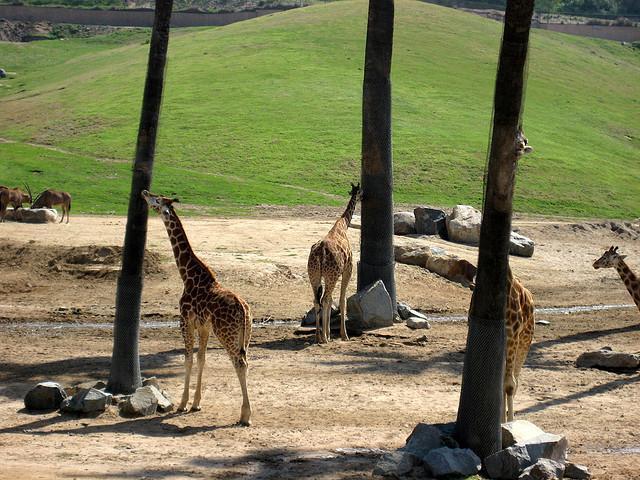How many trees are in the picture?
Give a very brief answer. 3. How many giraffes are in the picture?
Give a very brief answer. 4. 